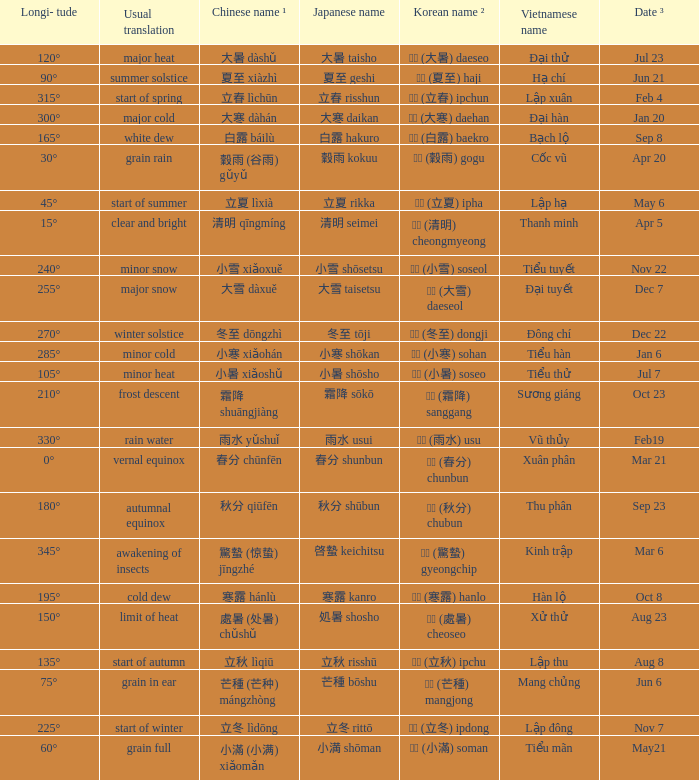When has a Korean name ² of 청명 (清明) cheongmyeong? Apr 5. Would you mind parsing the complete table? {'header': ['Longi- tude', 'Usual translation', 'Chinese name ¹', 'Japanese name', 'Korean name ²', 'Vietnamese name', 'Date ³'], 'rows': [['120°', 'major heat', '大暑 dàshǔ', '大暑 taisho', '대서 (大暑) daeseo', 'Đại thử', 'Jul 23'], ['90°', 'summer solstice', '夏至 xiàzhì', '夏至 geshi', '하지 (夏至) haji', 'Hạ chí', 'Jun 21'], ['315°', 'start of spring', '立春 lìchūn', '立春 risshun', '입춘 (立春) ipchun', 'Lập xuân', 'Feb 4'], ['300°', 'major cold', '大寒 dàhán', '大寒 daikan', '대한 (大寒) daehan', 'Đại hàn', 'Jan 20'], ['165°', 'white dew', '白露 báilù', '白露 hakuro', '백로 (白露) baekro', 'Bạch lộ', 'Sep 8'], ['30°', 'grain rain', '穀雨 (谷雨) gǔyǔ', '穀雨 kokuu', '곡우 (穀雨) gogu', 'Cốc vũ', 'Apr 20'], ['45°', 'start of summer', '立夏 lìxià', '立夏 rikka', '입하 (立夏) ipha', 'Lập hạ', 'May 6'], ['15°', 'clear and bright', '清明 qīngmíng', '清明 seimei', '청명 (清明) cheongmyeong', 'Thanh minh', 'Apr 5'], ['240°', 'minor snow', '小雪 xiǎoxuě', '小雪 shōsetsu', '소설 (小雪) soseol', 'Tiểu tuyết', 'Nov 22'], ['255°', 'major snow', '大雪 dàxuě', '大雪 taisetsu', '대설 (大雪) daeseol', 'Đại tuyết', 'Dec 7'], ['270°', 'winter solstice', '冬至 dōngzhì', '冬至 tōji', '동지 (冬至) dongji', 'Đông chí', 'Dec 22'], ['285°', 'minor cold', '小寒 xiǎohán', '小寒 shōkan', '소한 (小寒) sohan', 'Tiểu hàn', 'Jan 6'], ['105°', 'minor heat', '小暑 xiǎoshǔ', '小暑 shōsho', '소서 (小暑) soseo', 'Tiểu thử', 'Jul 7'], ['210°', 'frost descent', '霜降 shuāngjiàng', '霜降 sōkō', '상강 (霜降) sanggang', 'Sương giáng', 'Oct 23'], ['330°', 'rain water', '雨水 yǔshuǐ', '雨水 usui', '우수 (雨水) usu', 'Vũ thủy', 'Feb19'], ['0°', 'vernal equinox', '春分 chūnfēn', '春分 shunbun', '춘분 (春分) chunbun', 'Xuân phân', 'Mar 21'], ['180°', 'autumnal equinox', '秋分 qiūfēn', '秋分 shūbun', '추분 (秋分) chubun', 'Thu phân', 'Sep 23'], ['345°', 'awakening of insects', '驚蟄 (惊蛰) jīngzhé', '啓蟄 keichitsu', '경칩 (驚蟄) gyeongchip', 'Kinh trập', 'Mar 6'], ['195°', 'cold dew', '寒露 hánlù', '寒露 kanro', '한로 (寒露) hanlo', 'Hàn lộ', 'Oct 8'], ['150°', 'limit of heat', '處暑 (处暑) chǔshǔ', '処暑 shosho', '처서 (處暑) cheoseo', 'Xử thử', 'Aug 23'], ['135°', 'start of autumn', '立秋 lìqiū', '立秋 risshū', '입추 (立秋) ipchu', 'Lập thu', 'Aug 8'], ['75°', 'grain in ear', '芒種 (芒种) mángzhòng', '芒種 bōshu', '망종 (芒種) mangjong', 'Mang chủng', 'Jun 6'], ['225°', 'start of winter', '立冬 lìdōng', '立冬 rittō', '입동 (立冬) ipdong', 'Lập đông', 'Nov 7'], ['60°', 'grain full', '小滿 (小满) xiǎomǎn', '小満 shōman', '소만 (小滿) soman', 'Tiểu mãn', 'May21']]} 